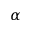Convert formula to latex. <formula><loc_0><loc_0><loc_500><loc_500>\alpha</formula> 